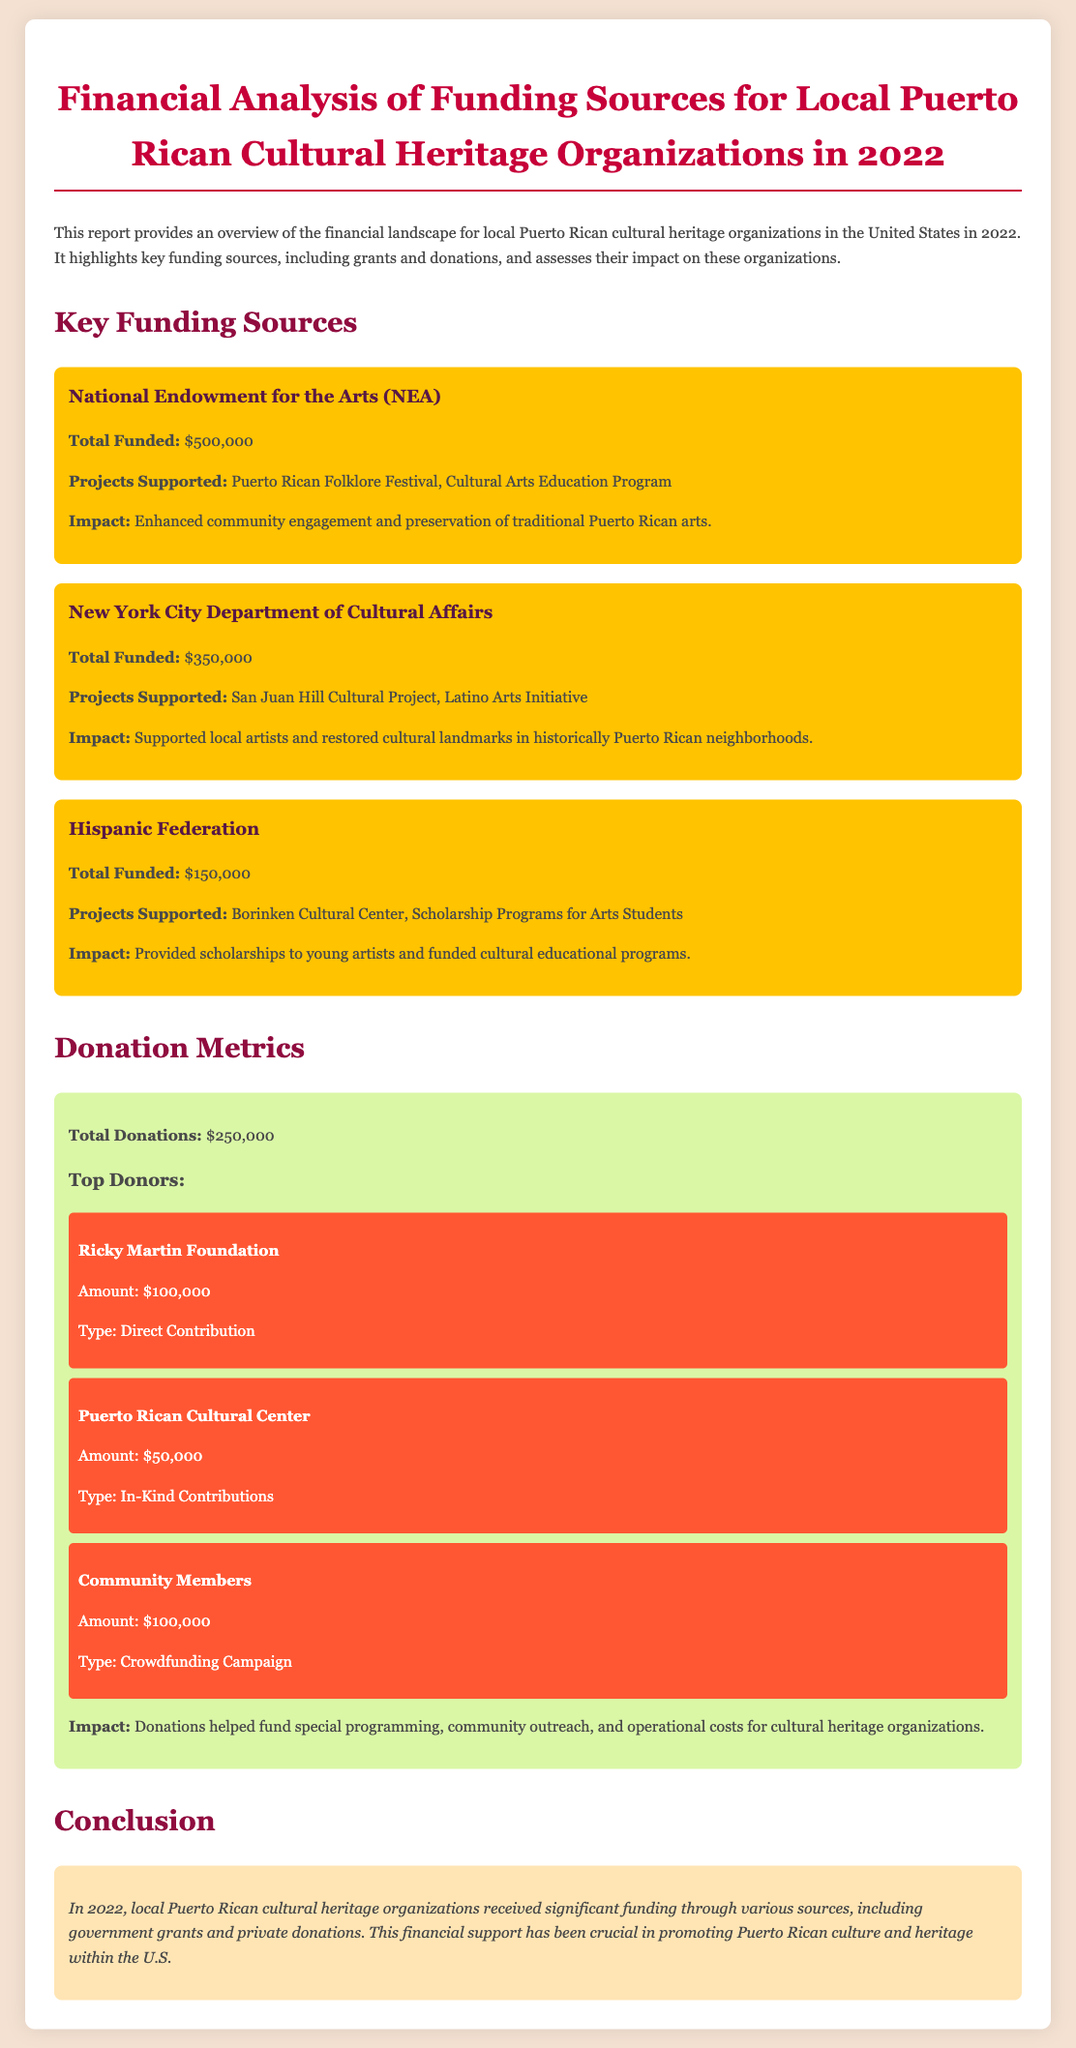What is the total funding from the National Endowment for the Arts? The total funding from the National Endowment for the Arts in the document is clearly stated as $500,000.
Answer: $500,000 What are the projects supported by the New York City Department of Cultural Affairs? The projects supported are specified in the document as San Juan Hill Cultural Project and Latino Arts Initiative.
Answer: San Juan Hill Cultural Project, Latino Arts Initiative Who was the top individual donor and how much did they contribute? The top individual donor is indicated in the document as the Ricky Martin Foundation, which contributed $100,000.
Answer: Ricky Martin Foundation, $100,000 How much total funding did organizations receive from the Hispanic Federation? The document reports that the Hispanic Federation funded a total of $150,000.
Answer: $150,000 What is the total amount of donations mentioned in the report? The report states that the total donations are $250,000.
Answer: $250,000 What impact did the donations have on the cultural heritage organizations? The document states that donations helped fund special programming, community outreach, and operational costs.
Answer: Special programming, community outreach, operational costs What is the total funding received from all listed sources combined? To find this, we add all funding sources: $500,000 + $350,000 + $150,000 = $1,000,000, a calculation derived from the detailed amounts provided.
Answer: $1,000,000 What is the conclusion of the financial analysis report? The conclusion summarizes that the funding received has been crucial for promoting Puerto Rican culture and heritage within the U.S.
Answer: Crucial for promoting Puerto Rican culture and heritage within the U.S What type of contributions did the Puerto Rican Cultural Center provide? The type of contribution from the Puerto Rican Cultural Center is noted as In-Kind Contributions.
Answer: In-Kind Contributions Which funding source primarily supports scholarships for young artists? The document notes that the Hispanic Federation supports scholarships for young artists as part of its funded projects.
Answer: Hispanic Federation 